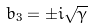<formula> <loc_0><loc_0><loc_500><loc_500>b _ { 3 } = \pm i \sqrt { \gamma }</formula> 